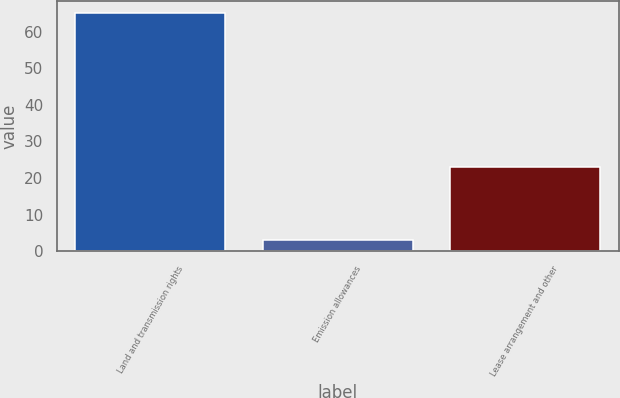Convert chart to OTSL. <chart><loc_0><loc_0><loc_500><loc_500><bar_chart><fcel>Land and transmission rights<fcel>Emission allowances<fcel>Lease arrangement and other<nl><fcel>65<fcel>3<fcel>23<nl></chart> 